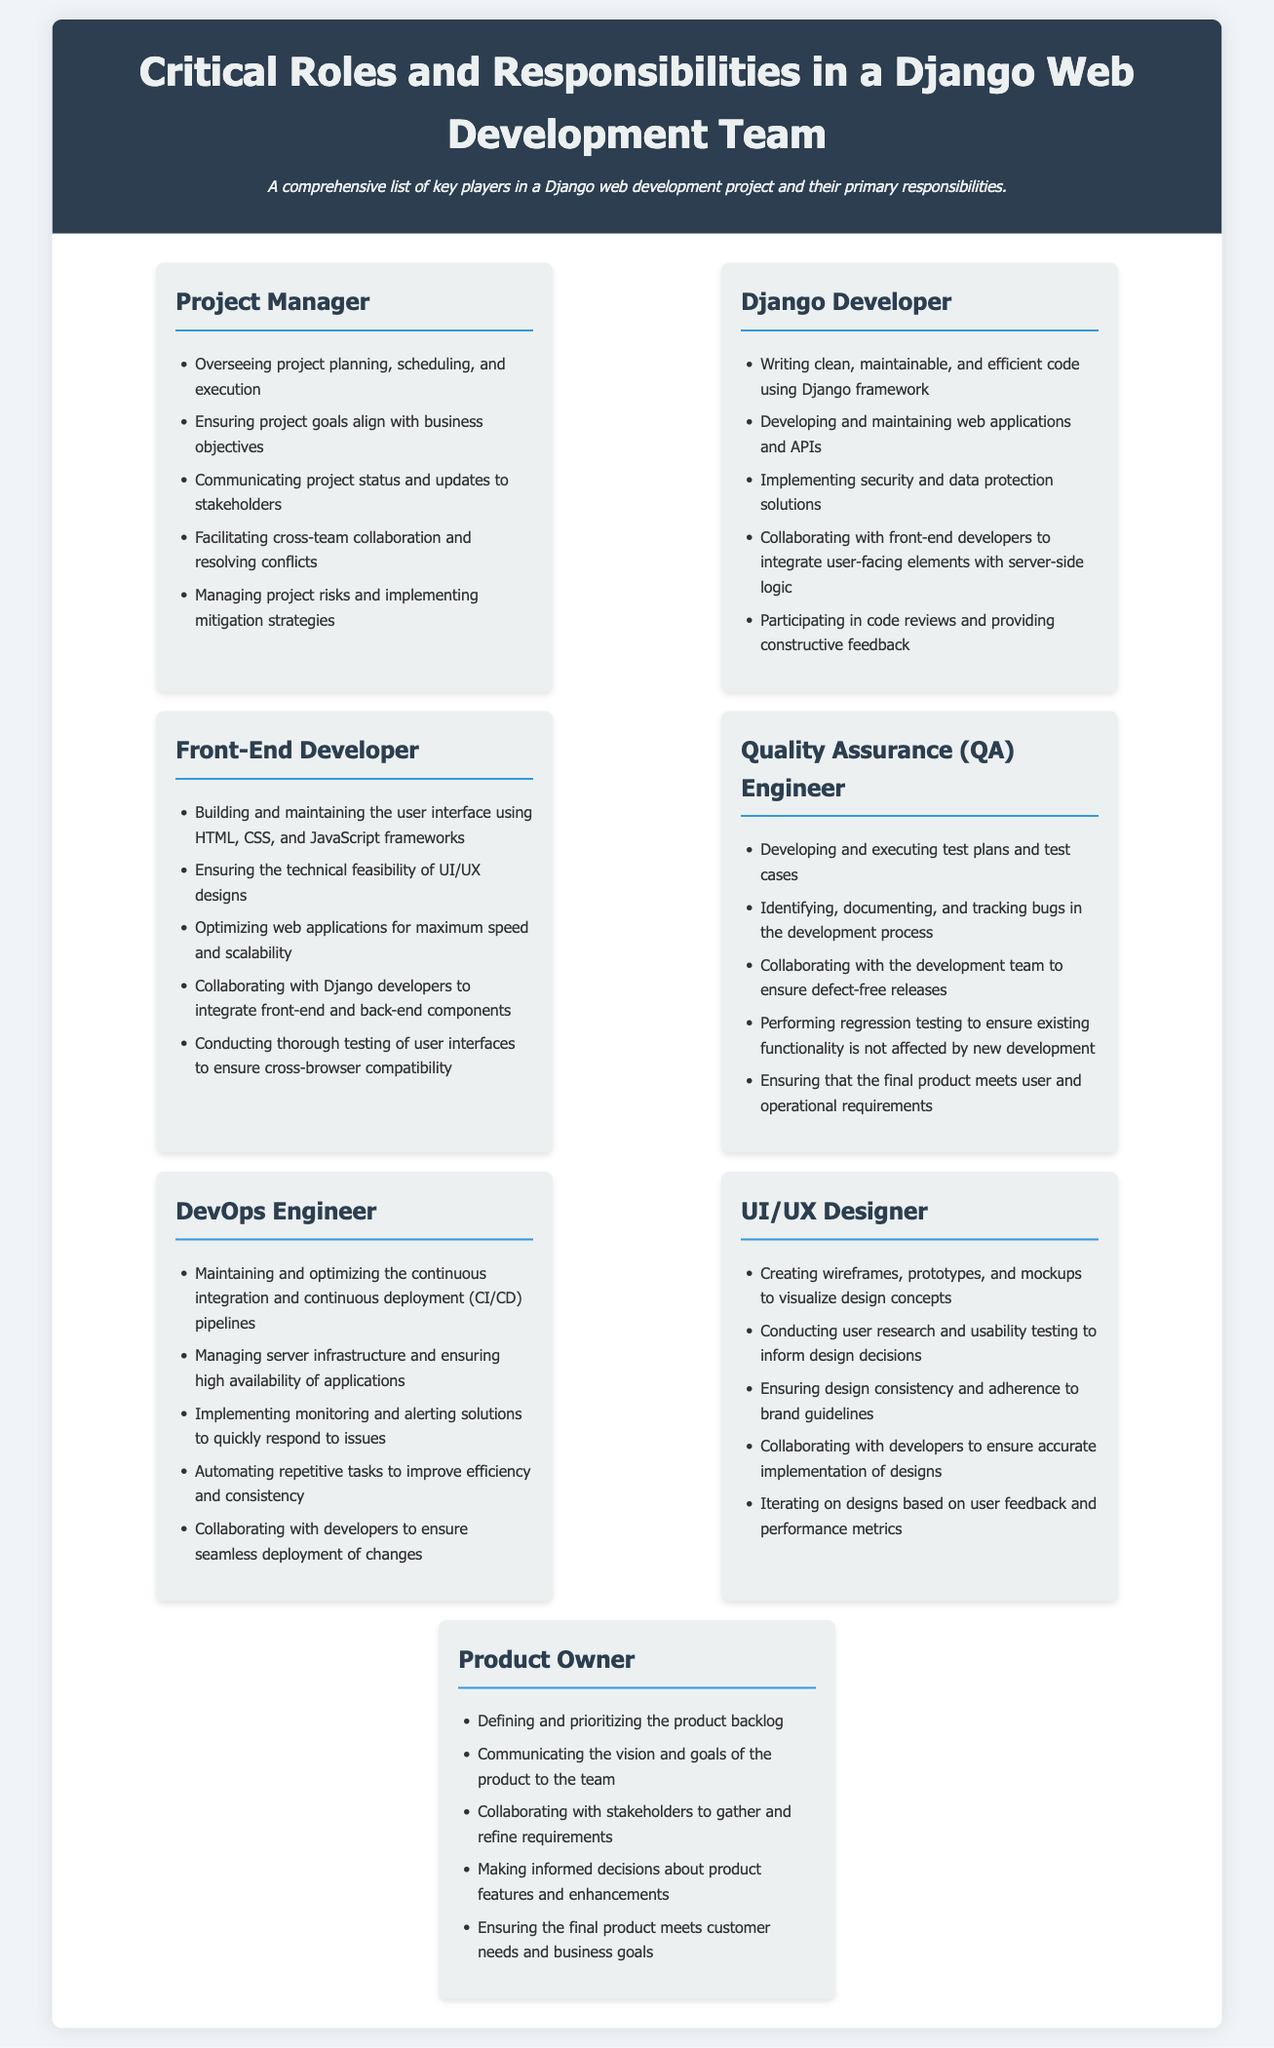What is the first role listed in the document? The first role mentioned in the document is the Project Manager.
Answer: Project Manager How many roles are described in the document? The document describes seven distinct roles involved in a Django web development team.
Answer: Seven What is one responsibility of the Django Developer? The responsibilities of the Django Developer include writing clean, maintainable, and efficient code using the Django framework.
Answer: Writing clean, maintainable, and efficient code Which role is responsible for conducting user research? The role responsible for conducting user research is the UI/UX Designer.
Answer: UI/UX Designer What does the Quality Assurance Engineer ensure? The Quality Assurance Engineer ensures that the final product meets user and operational requirements.
Answer: Meets user and operational requirements Which position is tasked with managing server infrastructure? The position tasked with managing server infrastructure is the DevOps Engineer.
Answer: DevOps Engineer Who is responsible for defining and prioritizing the product backlog? The Product Owner is responsible for defining and prioritizing the product backlog.
Answer: Product Owner How often should the Django Developer participate in code reviews? The Django Developer should participate in code reviews, but the frequency is not specified.
Answer: Participating in code reviews 